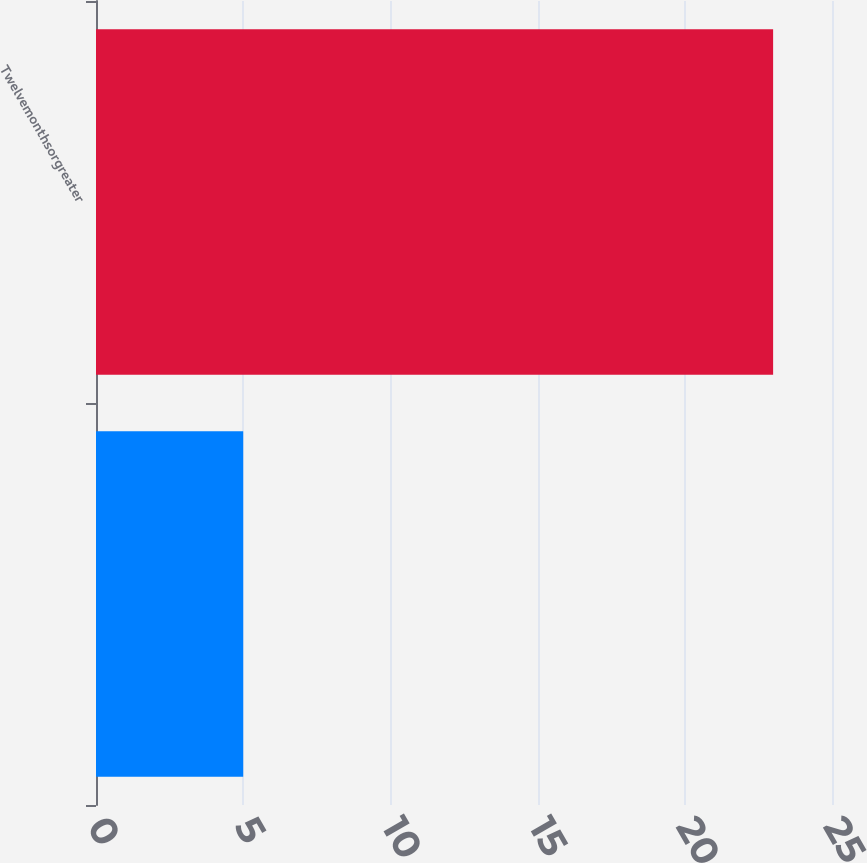Convert chart to OTSL. <chart><loc_0><loc_0><loc_500><loc_500><bar_chart><ecel><fcel>Twelvemonthsorgreater<nl><fcel>5<fcel>23<nl></chart> 